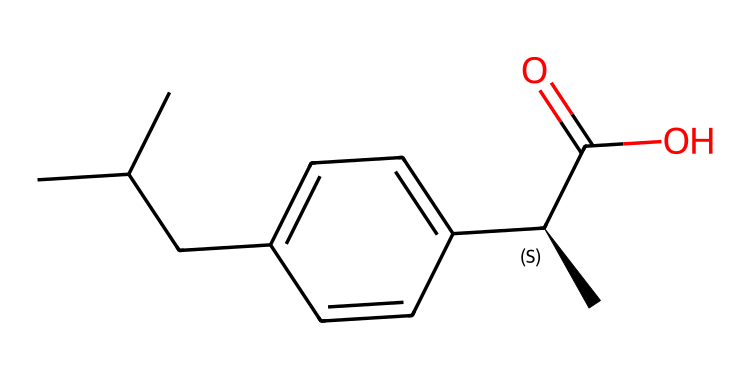What is the molecular formula of ibuprofen? To determine the molecular formula, count the number of each type of atom in the SMILES representation. The structure includes 13 carbon (C), 18 hydrogen (H), and 2 oxygen (O) atoms. Therefore, the molecular formula is C13H18O2.
Answer: C13H18O2 How many chiral centers are present in ibuprofen? Analyze the chemical structure for any chiral centers, which are carbon atoms bonded to four different groups. In this SMILES, there is one chiral carbon indicated by the [C@H] notation. Thus, there is one chiral center.
Answer: 1 What functional groups are present in ibuprofen? Identify the functional groups present in the chemical. The structure includes a carboxylic acid (-COOH) and an aliphatic chain along with the aromatic ring. The carboxylate is indicated by C(=O)O. Therefore, its main functional group is the carboxylic acid.
Answer: carboxylic acid What type of isomerism does ibuprofen exhibit? Assess the presence of a chiral center, which can lead to different configurations, indicating the potential for optical isomerism. Given the chiral center in ibuprofen, it can exist in two enantiomers, exhibiting optical isomerism.
Answer: optical isomerism How many hydrogen atoms are bonded to the aromatic ring in ibuprofen? Examine the aromatic ring section of the structure, which consists of five carbon atoms in a ring. Each of the four carbons in the ring is directly connected to one hydrogen atom, leading to four hydrogens in total.
Answer: 4 